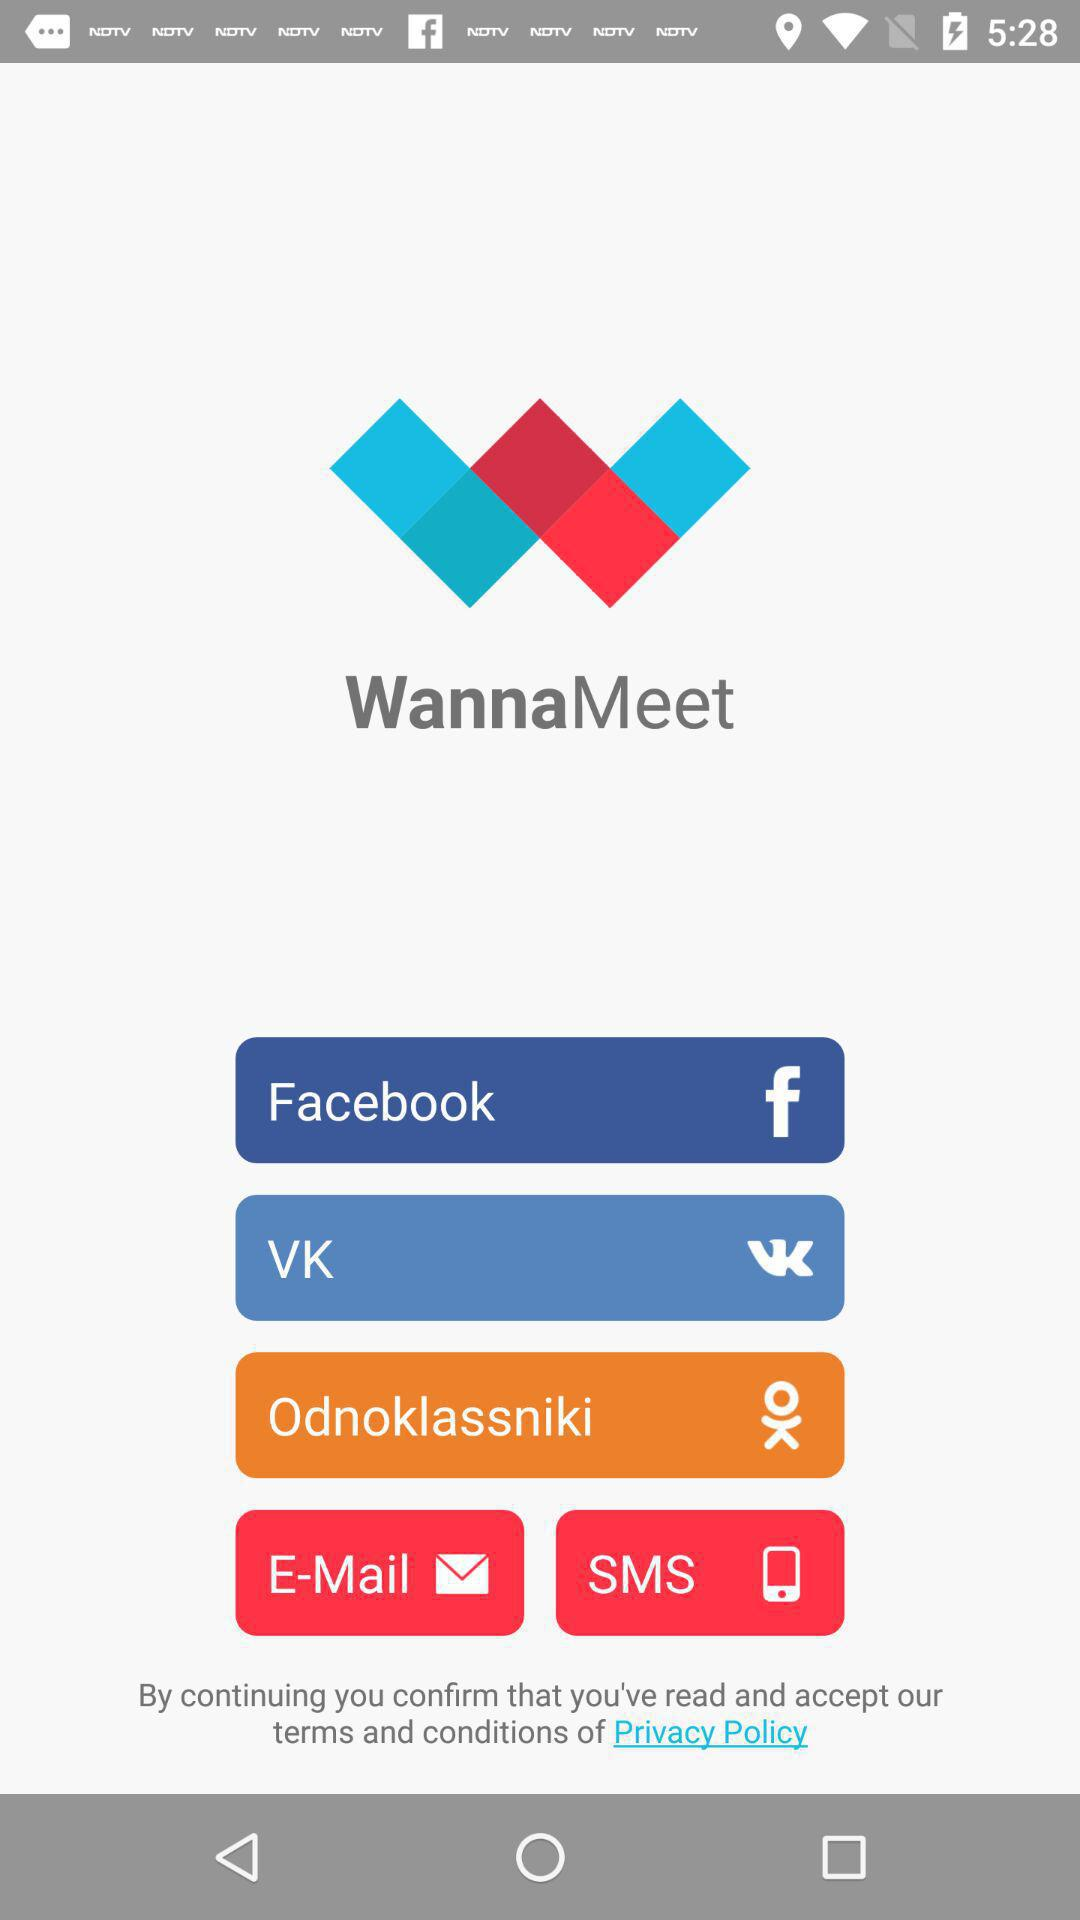What is the application name? The application name is "WannaMeet". 